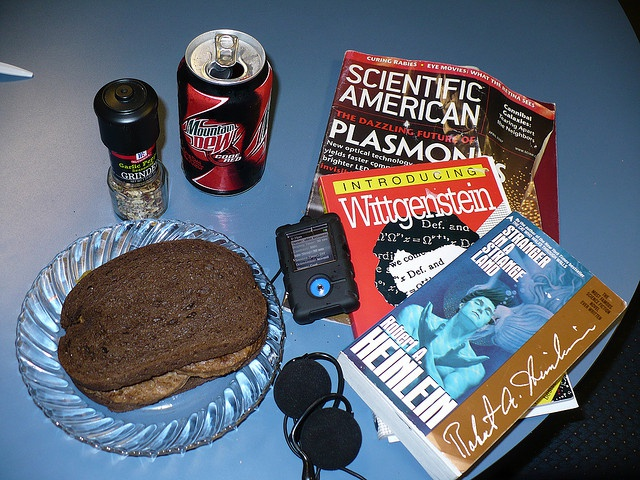Describe the objects in this image and their specific colors. I can see book in black, white, olive, and gray tones, sandwich in black, maroon, and gray tones, book in black, maroon, white, and gray tones, book in black, white, and red tones, and bottle in black, gray, darkgray, and maroon tones in this image. 